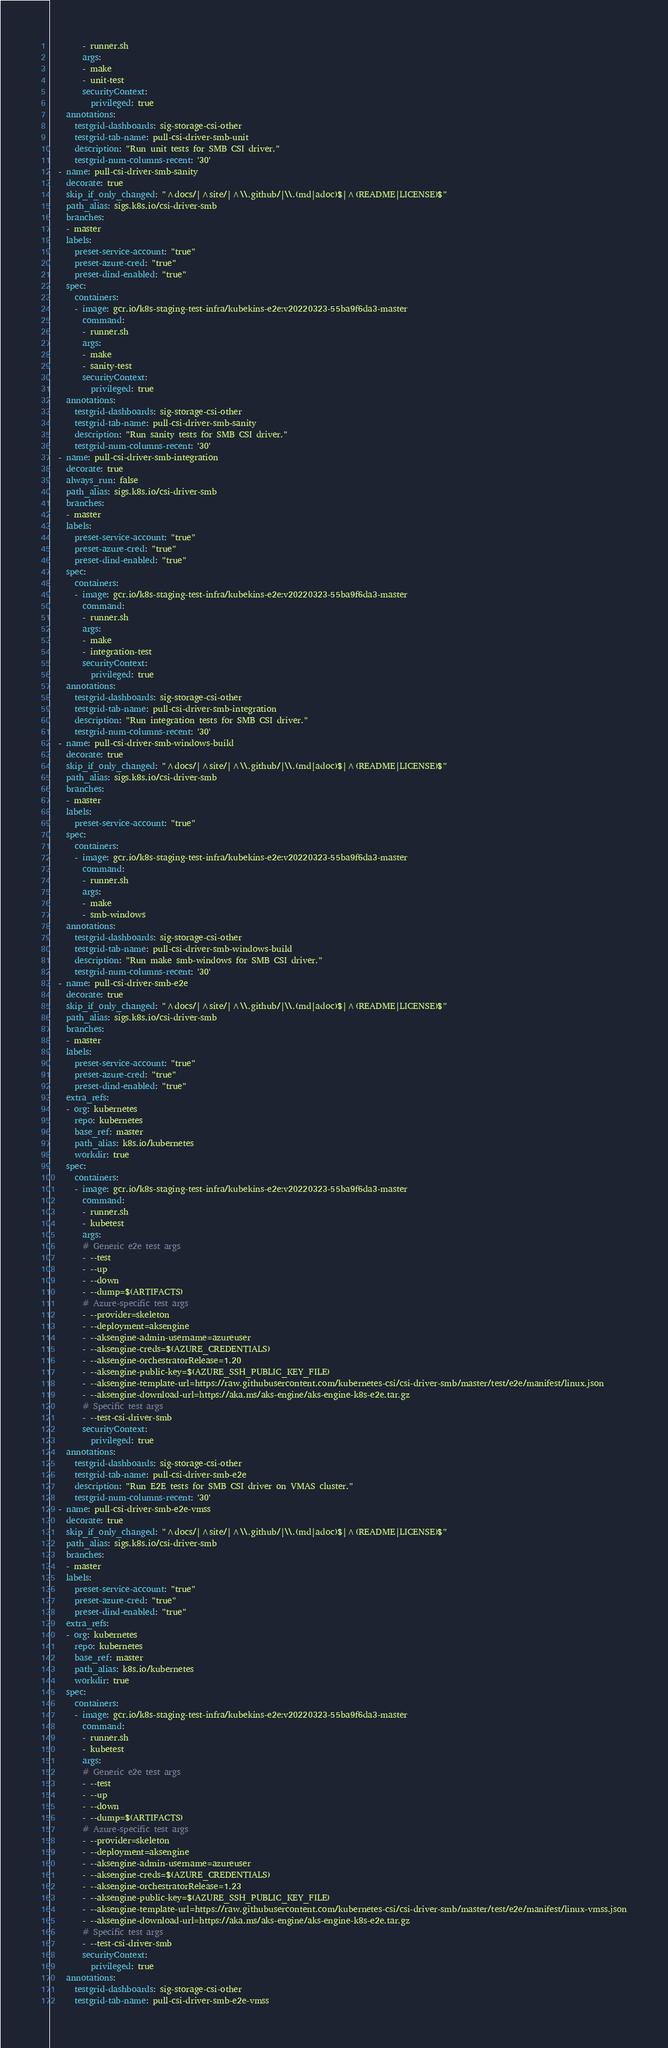Convert code to text. <code><loc_0><loc_0><loc_500><loc_500><_YAML_>        - runner.sh
        args:
        - make
        - unit-test
        securityContext:
          privileged: true
    annotations:
      testgrid-dashboards: sig-storage-csi-other
      testgrid-tab-name: pull-csi-driver-smb-unit
      description: "Run unit tests for SMB CSI driver."
      testgrid-num-columns-recent: '30'
  - name: pull-csi-driver-smb-sanity
    decorate: true
    skip_if_only_changed: "^docs/|^site/|^\\.github/|\\.(md|adoc)$|^(README|LICENSE)$"
    path_alias: sigs.k8s.io/csi-driver-smb
    branches:
    - master
    labels:
      preset-service-account: "true"
      preset-azure-cred: "true"
      preset-dind-enabled: "true"
    spec:
      containers:
      - image: gcr.io/k8s-staging-test-infra/kubekins-e2e:v20220323-55ba9f6da3-master
        command:
        - runner.sh
        args:
        - make
        - sanity-test
        securityContext:
          privileged: true
    annotations:
      testgrid-dashboards: sig-storage-csi-other
      testgrid-tab-name: pull-csi-driver-smb-sanity
      description: "Run sanity tests for SMB CSI driver."
      testgrid-num-columns-recent: '30'
  - name: pull-csi-driver-smb-integration
    decorate: true
    always_run: false
    path_alias: sigs.k8s.io/csi-driver-smb
    branches:
    - master
    labels:
      preset-service-account: "true"
      preset-azure-cred: "true"
      preset-dind-enabled: "true"
    spec:
      containers:
      - image: gcr.io/k8s-staging-test-infra/kubekins-e2e:v20220323-55ba9f6da3-master
        command:
        - runner.sh
        args:
        - make
        - integration-test
        securityContext:
          privileged: true
    annotations:
      testgrid-dashboards: sig-storage-csi-other
      testgrid-tab-name: pull-csi-driver-smb-integration
      description: "Run integration tests for SMB CSI driver."
      testgrid-num-columns-recent: '30'
  - name: pull-csi-driver-smb-windows-build
    decorate: true
    skip_if_only_changed: "^docs/|^site/|^\\.github/|\\.(md|adoc)$|^(README|LICENSE)$"
    path_alias: sigs.k8s.io/csi-driver-smb
    branches:
    - master
    labels:
      preset-service-account: "true"
    spec:
      containers:
      - image: gcr.io/k8s-staging-test-infra/kubekins-e2e:v20220323-55ba9f6da3-master
        command:
        - runner.sh
        args:
        - make
        - smb-windows
    annotations:
      testgrid-dashboards: sig-storage-csi-other
      testgrid-tab-name: pull-csi-driver-smb-windows-build
      description: "Run make smb-windows for SMB CSI driver."
      testgrid-num-columns-recent: '30'
  - name: pull-csi-driver-smb-e2e
    decorate: true
    skip_if_only_changed: "^docs/|^site/|^\\.github/|\\.(md|adoc)$|^(README|LICENSE)$"
    path_alias: sigs.k8s.io/csi-driver-smb
    branches:
    - master
    labels:
      preset-service-account: "true"
      preset-azure-cred: "true"
      preset-dind-enabled: "true"
    extra_refs:
    - org: kubernetes
      repo: kubernetes
      base_ref: master
      path_alias: k8s.io/kubernetes
      workdir: true
    spec:
      containers:
      - image: gcr.io/k8s-staging-test-infra/kubekins-e2e:v20220323-55ba9f6da3-master
        command:
        - runner.sh
        - kubetest
        args:
        # Generic e2e test args
        - --test
        - --up
        - --down
        - --dump=$(ARTIFACTS)
        # Azure-specific test args
        - --provider=skeleton
        - --deployment=aksengine
        - --aksengine-admin-username=azureuser
        - --aksengine-creds=$(AZURE_CREDENTIALS)
        - --aksengine-orchestratorRelease=1.20
        - --aksengine-public-key=$(AZURE_SSH_PUBLIC_KEY_FILE)
        - --aksengine-template-url=https://raw.githubusercontent.com/kubernetes-csi/csi-driver-smb/master/test/e2e/manifest/linux.json
        - --aksengine-download-url=https://aka.ms/aks-engine/aks-engine-k8s-e2e.tar.gz
        # Specific test args
        - --test-csi-driver-smb
        securityContext:
          privileged: true
    annotations:
      testgrid-dashboards: sig-storage-csi-other
      testgrid-tab-name: pull-csi-driver-smb-e2e
      description: "Run E2E tests for SMB CSI driver on VMAS cluster."
      testgrid-num-columns-recent: '30'
  - name: pull-csi-driver-smb-e2e-vmss
    decorate: true
    skip_if_only_changed: "^docs/|^site/|^\\.github/|\\.(md|adoc)$|^(README|LICENSE)$"
    path_alias: sigs.k8s.io/csi-driver-smb
    branches:
    - master
    labels:
      preset-service-account: "true"
      preset-azure-cred: "true"
      preset-dind-enabled: "true"
    extra_refs:
    - org: kubernetes
      repo: kubernetes
      base_ref: master
      path_alias: k8s.io/kubernetes
      workdir: true
    spec:
      containers:
      - image: gcr.io/k8s-staging-test-infra/kubekins-e2e:v20220323-55ba9f6da3-master
        command:
        - runner.sh
        - kubetest
        args:
        # Generic e2e test args
        - --test
        - --up
        - --down
        - --dump=$(ARTIFACTS)
        # Azure-specific test args
        - --provider=skeleton
        - --deployment=aksengine
        - --aksengine-admin-username=azureuser
        - --aksengine-creds=$(AZURE_CREDENTIALS)
        - --aksengine-orchestratorRelease=1.23
        - --aksengine-public-key=$(AZURE_SSH_PUBLIC_KEY_FILE)
        - --aksengine-template-url=https://raw.githubusercontent.com/kubernetes-csi/csi-driver-smb/master/test/e2e/manifest/linux-vmss.json
        - --aksengine-download-url=https://aka.ms/aks-engine/aks-engine-k8s-e2e.tar.gz
        # Specific test args
        - --test-csi-driver-smb
        securityContext:
          privileged: true
    annotations:
      testgrid-dashboards: sig-storage-csi-other
      testgrid-tab-name: pull-csi-driver-smb-e2e-vmss</code> 